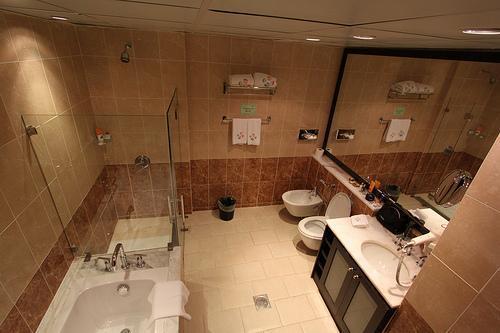How many sinks are in the bathroom?
Give a very brief answer. 1. 